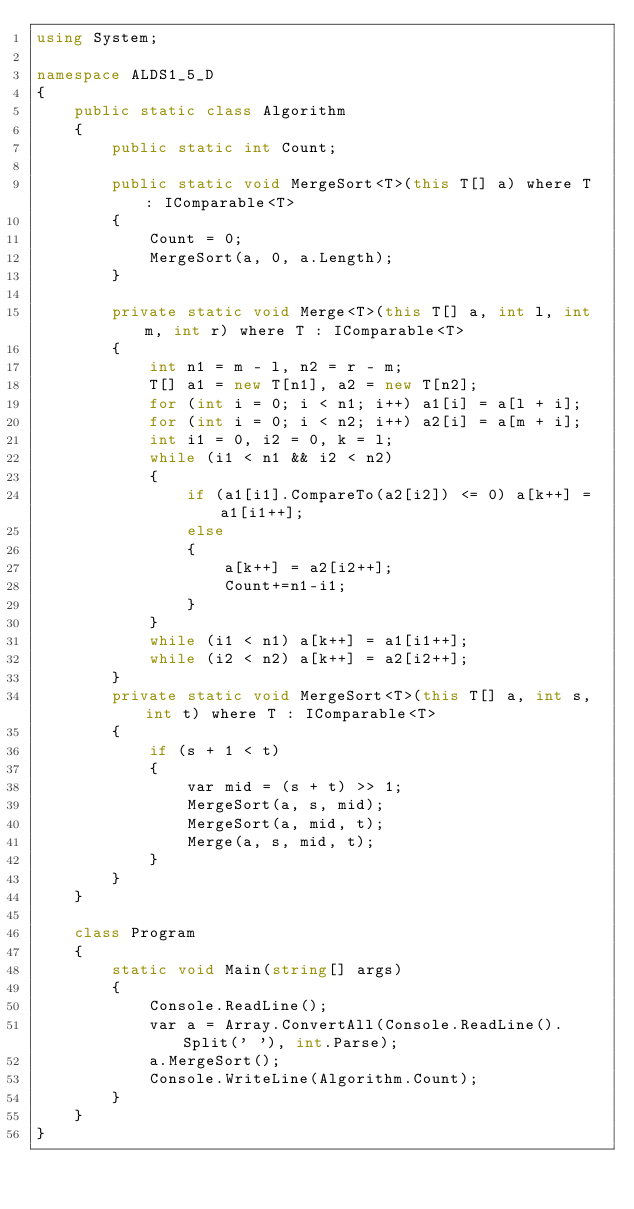<code> <loc_0><loc_0><loc_500><loc_500><_C#_>using System;

namespace ALDS1_5_D
{
    public static class Algorithm
    {
        public static int Count;

        public static void MergeSort<T>(this T[] a) where T : IComparable<T>
        {
            Count = 0;
            MergeSort(a, 0, a.Length);
        }

        private static void Merge<T>(this T[] a, int l, int m, int r) where T : IComparable<T>
        {
            int n1 = m - l, n2 = r - m;
            T[] a1 = new T[n1], a2 = new T[n2];
            for (int i = 0; i < n1; i++) a1[i] = a[l + i];
            for (int i = 0; i < n2; i++) a2[i] = a[m + i];
            int i1 = 0, i2 = 0, k = l;
            while (i1 < n1 && i2 < n2)
            {
                if (a1[i1].CompareTo(a2[i2]) <= 0) a[k++] = a1[i1++];
                else
                {
                    a[k++] = a2[i2++];
                    Count+=n1-i1;
                }
            }
            while (i1 < n1) a[k++] = a1[i1++];
            while (i2 < n2) a[k++] = a2[i2++];
        }
        private static void MergeSort<T>(this T[] a, int s, int t) where T : IComparable<T>
        {
            if (s + 1 < t)
            {
                var mid = (s + t) >> 1;
                MergeSort(a, s, mid);
                MergeSort(a, mid, t);
                Merge(a, s, mid, t);
            }
        }
    }

    class Program
    {
        static void Main(string[] args)
        {
            Console.ReadLine();
            var a = Array.ConvertAll(Console.ReadLine().Split(' '), int.Parse);
            a.MergeSort();
            Console.WriteLine(Algorithm.Count);
        }
    }
}</code> 